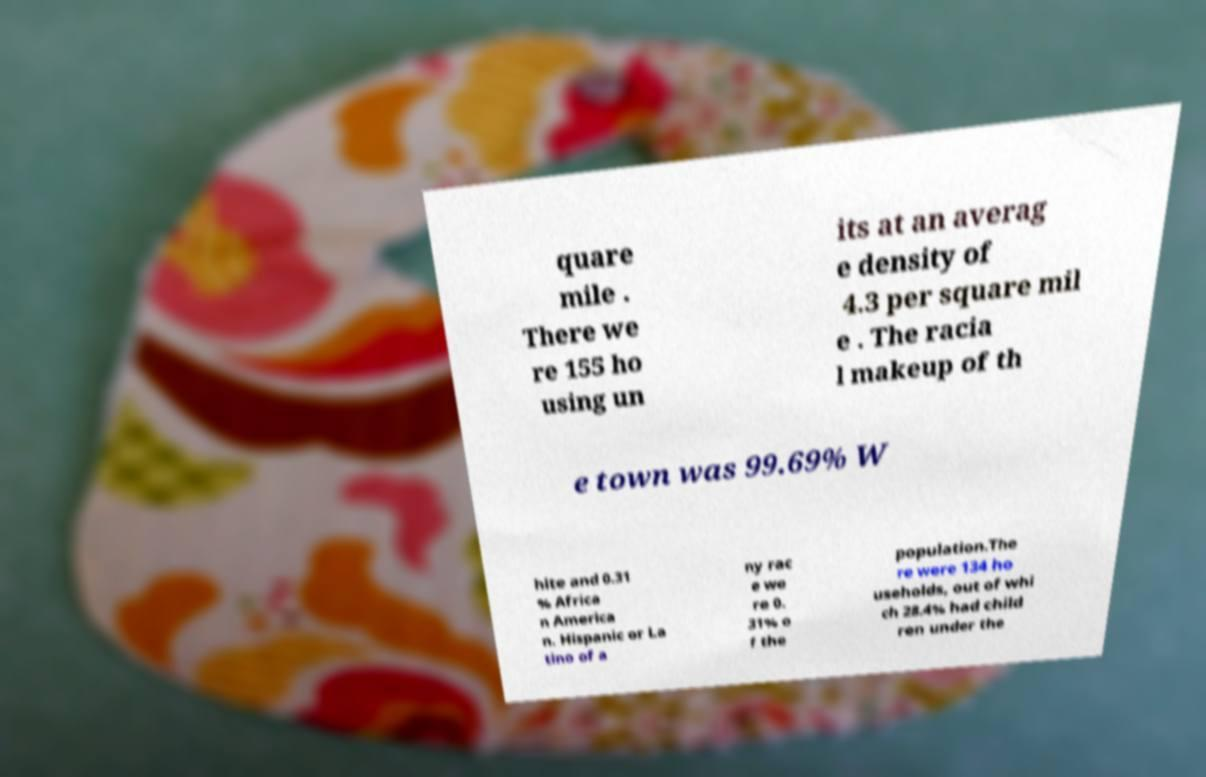Please read and relay the text visible in this image. What does it say? quare mile . There we re 155 ho using un its at an averag e density of 4.3 per square mil e . The racia l makeup of th e town was 99.69% W hite and 0.31 % Africa n America n. Hispanic or La tino of a ny rac e we re 0. 31% o f the population.The re were 134 ho useholds, out of whi ch 28.4% had child ren under the 